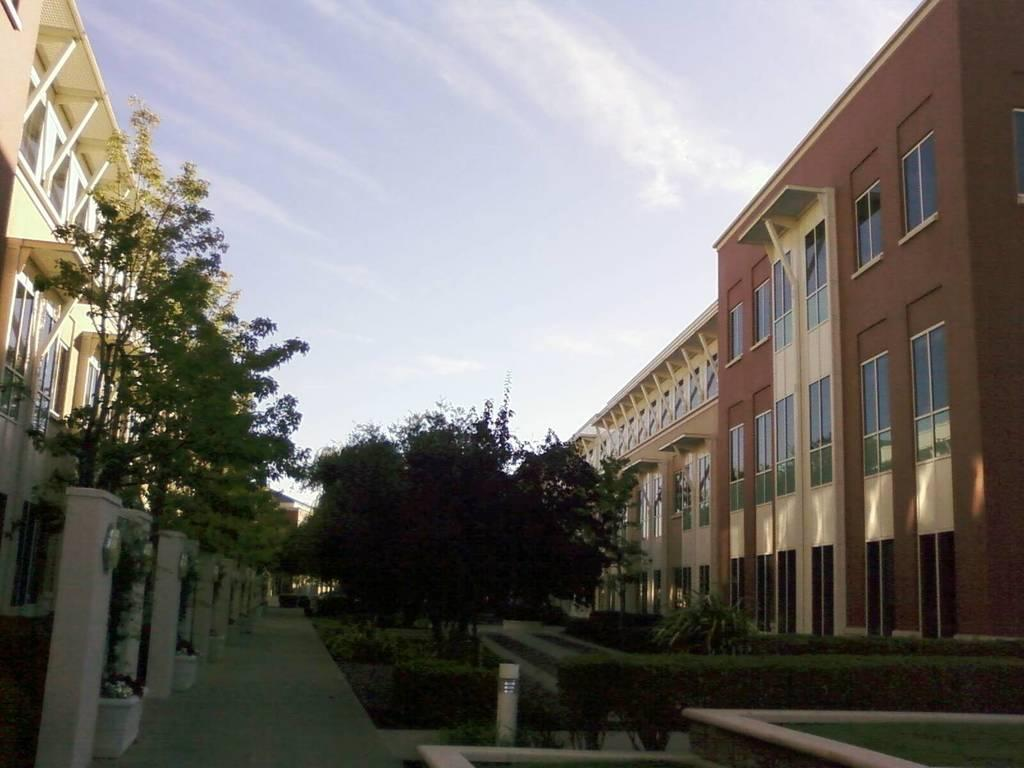What type of natural elements are present in the middle of the image? There are trees and plants in the middle of the image. What type of man-made structures are present in the middle of the image? There are buildings in the middle of the image. What can be seen in the sky at the top of the image? Clouds and the sky are visible at the top of the image. What type of scent can be detected from the trees and plants in the image? There is no information about the scent of the trees and plants in the image, so it cannot be determined. 